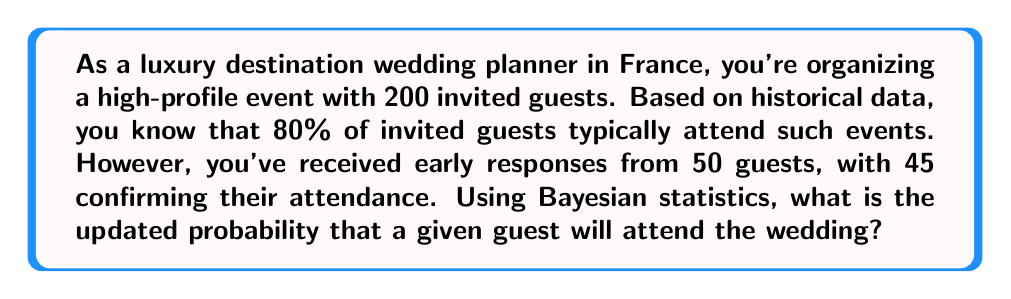Provide a solution to this math problem. Let's approach this problem using Bayesian statistics:

1) Define our variables:
   $A$ = Event that a guest attends
   $E$ = Evidence of early responses

2) We need to calculate $P(A|E)$, the probability of attendance given the early responses.

3) Bayes' theorem states:

   $$P(A|E) = \frac{P(E|A) \cdot P(A)}{P(E)}$$

4) We know:
   $P(A) = 0.8$ (prior probability of attendance)
   $P(E|A) = 45/50 = 0.9$ (likelihood of early response given attendance)
   
5) We need to calculate $P(E)$:
   $P(E) = P(E|A) \cdot P(A) + P(E|\neg A) \cdot P(\neg A)$
   
   Where $P(E|\neg A)$ is the probability of early response given non-attendance, which is $5/50 = 0.1$
   
   $P(E) = 0.9 \cdot 0.8 + 0.1 \cdot 0.2 = 0.74$

6) Now we can apply Bayes' theorem:

   $$P(A|E) = \frac{0.9 \cdot 0.8}{0.74} \approx 0.9730$$

Therefore, the updated probability of attendance for a given guest is approximately 0.9730 or 97.30%.
Answer: 0.9730 or 97.30% 